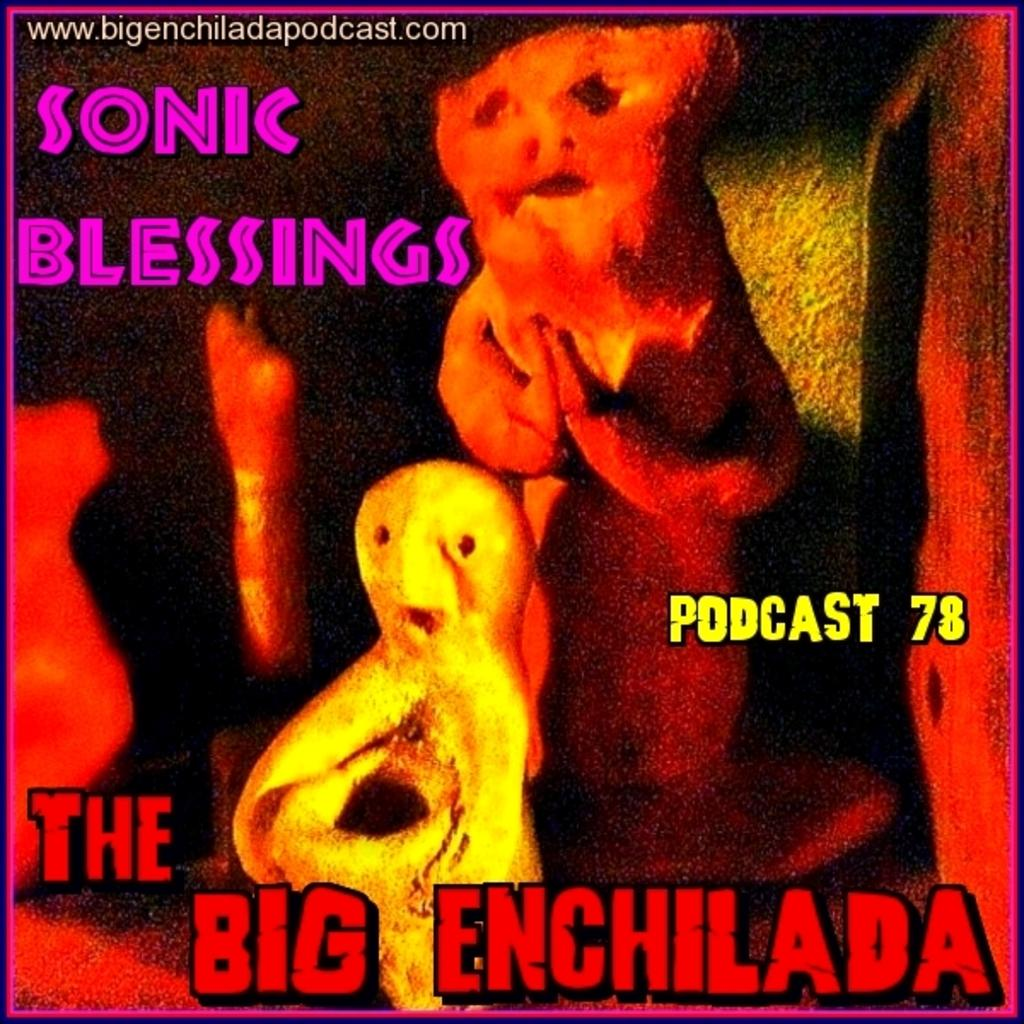<image>
Describe the image concisely. a sign with the words the big enchilada 